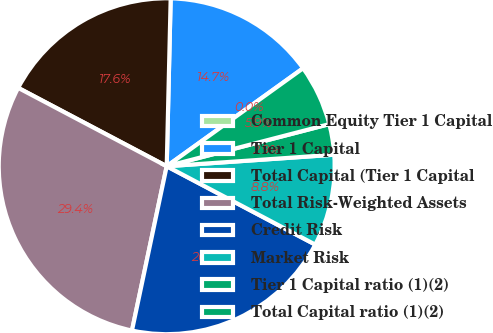Convert chart to OTSL. <chart><loc_0><loc_0><loc_500><loc_500><pie_chart><fcel>Common Equity Tier 1 Capital<fcel>Tier 1 Capital<fcel>Total Capital (Tier 1 Capital<fcel>Total Risk-Weighted Assets<fcel>Credit Risk<fcel>Market Risk<fcel>Tier 1 Capital ratio (1)(2)<fcel>Total Capital ratio (1)(2)<nl><fcel>0.0%<fcel>14.71%<fcel>17.65%<fcel>29.41%<fcel>20.59%<fcel>8.82%<fcel>2.94%<fcel>5.88%<nl></chart> 